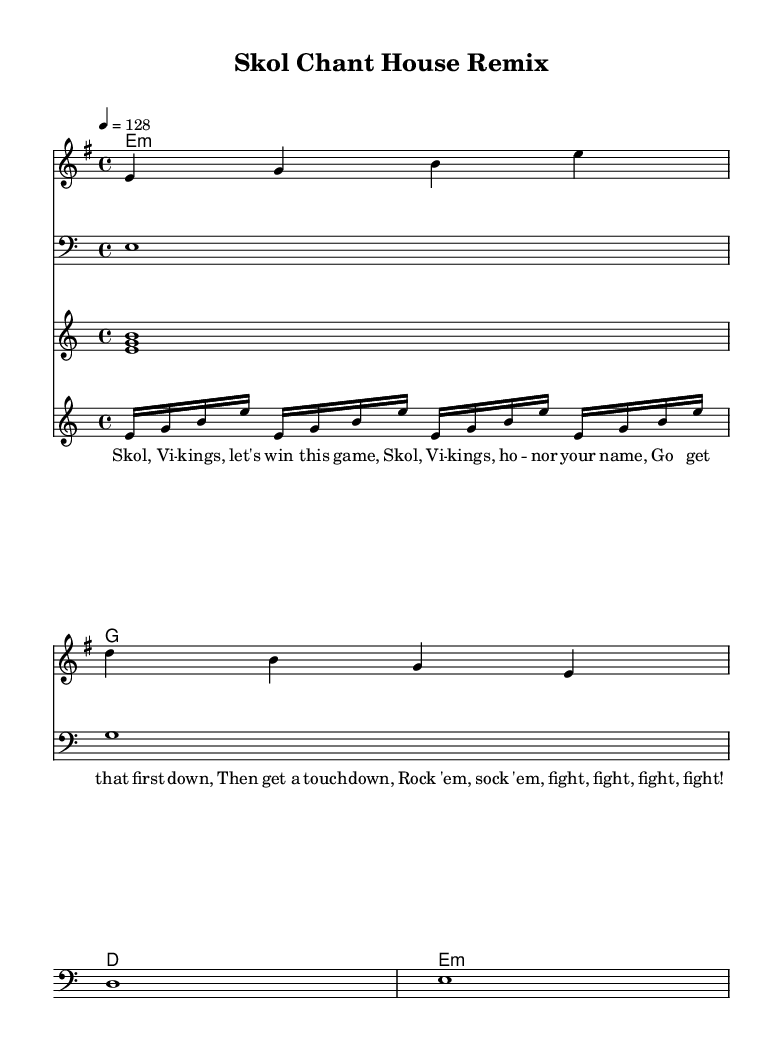What is the key signature of this music? The key signature is E minor, which has one sharp (F#). You can determine the key signature by looking at the beginning of the score, where the key is indicated.
Answer: E minor What is the time signature of this music? The time signature is 4/4, indicating that there are four beats in each measure and a quarter note receives one beat. This is also located at the beginning of the score.
Answer: 4/4 What is the tempo marking for this music? The tempo marking is 128 beats per minute, specified at the beginning of the score with the terms indicating the speed. You can find it under the tempo text like "4 = 128."
Answer: 128 How many measures are in the scored melody? The scored melody has four measures, each separated by a vertical line. Counting each segment between the bar lines gives you the total number of measures present in the melody part.
Answer: 4 What rhythmic pattern is used in the arpeggiator section? The rhythmic pattern in the arpeggiator section consists of four sixteenth notes repeated, giving a fast, energetic feel typical of house music. This pattern is indicated by the notation in that staff section.
Answer: Four sixteenth notes What type of harmony is primarily used in this remix? The harmony consists of simple triads that create a minor sound, specifically E minor, G major, D major, and E minor, indicated in the chord names section. This can be derived from analyzing the chord symbols written above the staff.
Answer: Triads What lyrical theme is present in this fight song? The lyrical theme is centered around encouragement and support for the Minnesota Vikings with phrases like "Skol, Vikings, let's win this game." This is evident from the lyrics provided along with the score.
Answer: Support for the Vikings 